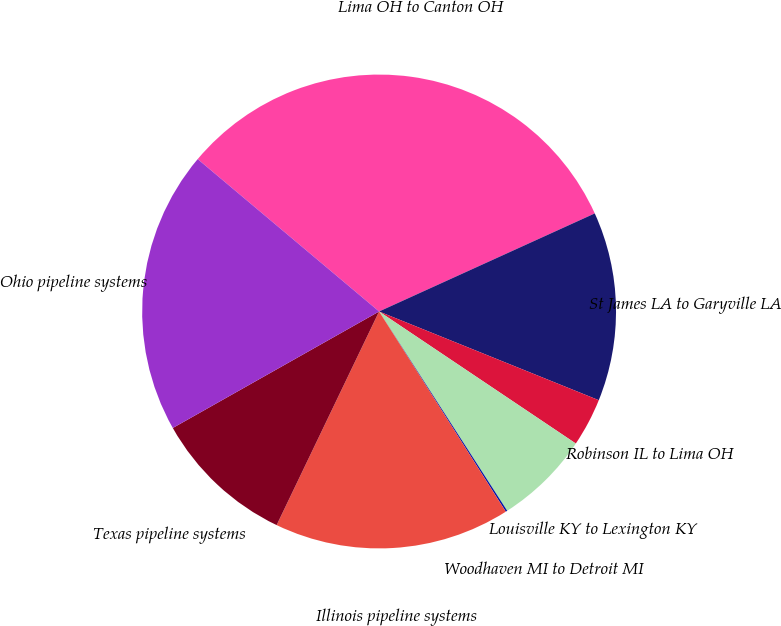Convert chart. <chart><loc_0><loc_0><loc_500><loc_500><pie_chart><fcel>Lima OH to Canton OH<fcel>St James LA to Garyville LA<fcel>Robinson IL to Lima OH<fcel>Louisville KY to Lexington KY<fcel>Woodhaven MI to Detroit MI<fcel>Illinois pipeline systems<fcel>Texas pipeline systems<fcel>Ohio pipeline systems<nl><fcel>32.09%<fcel>12.9%<fcel>3.3%<fcel>6.5%<fcel>0.11%<fcel>16.1%<fcel>9.7%<fcel>19.3%<nl></chart> 